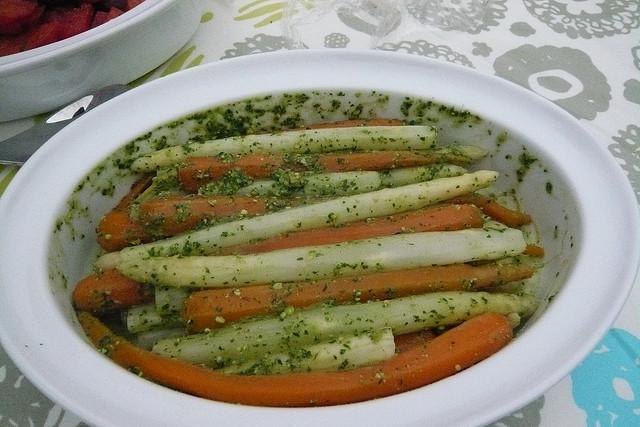How many bowls are in the photo?
Give a very brief answer. 2. How many carrots can be seen?
Give a very brief answer. 6. How many cows are in the photo?
Give a very brief answer. 0. 